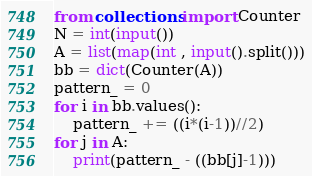Convert code to text. <code><loc_0><loc_0><loc_500><loc_500><_Python_>from collections import Counter
N = int(input())
A = list(map(int , input().split()))
bb = dict(Counter(A))
pattern_ = 0
for i in bb.values():
    pattern_ += ((i*(i-1))//2)
for j in A:
    print(pattern_ - ((bb[j]-1)))</code> 